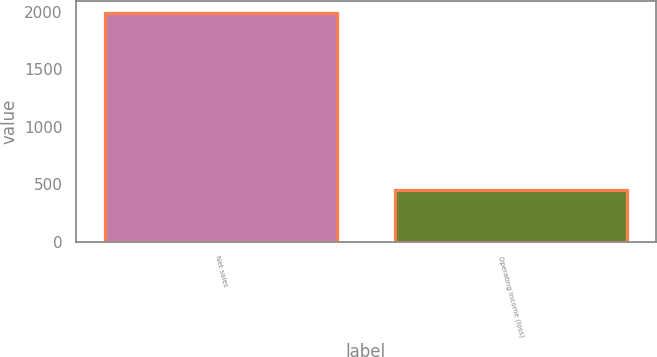<chart> <loc_0><loc_0><loc_500><loc_500><bar_chart><fcel>Net sales<fcel>Operating income (loss)<nl><fcel>1990<fcel>453<nl></chart> 